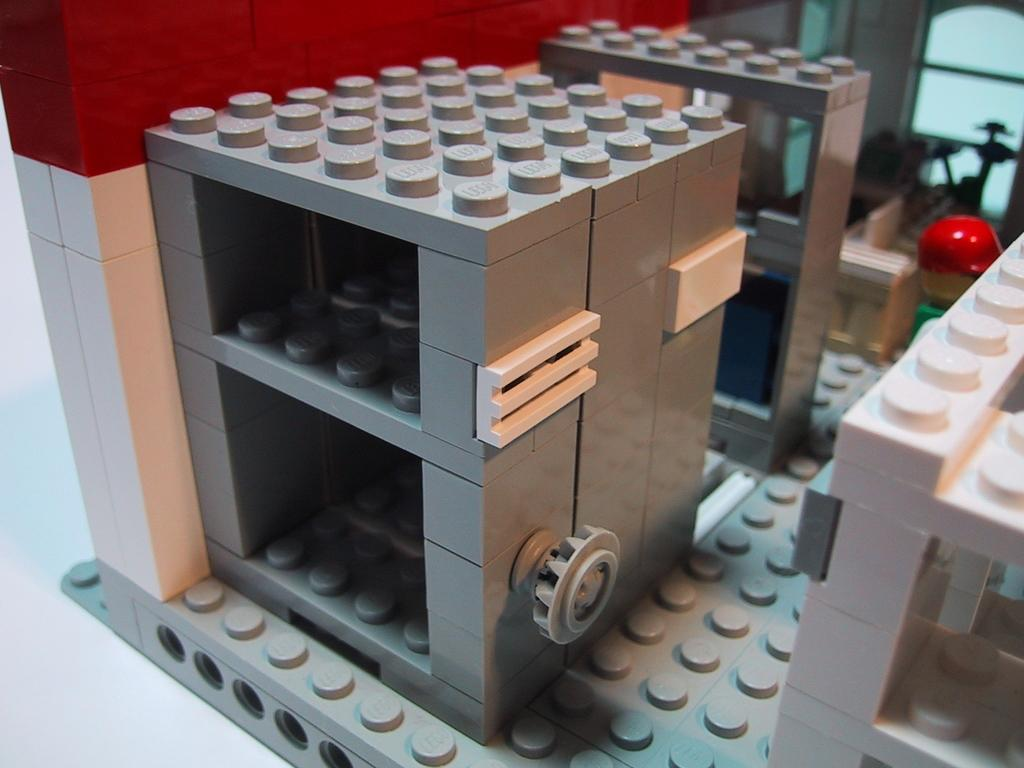What type of toy is present in the image? There are Lego bricks in the image. What other items can be seen in the image besides the Lego bricks? There are other unspecified objects in the image. What type of force can be seen acting upon the Lego bricks in the image? There is no force acting upon the Lego bricks in the image; they are stationary. Is there a hill visible in the background of the image? There is no hill present in the image. Can you see a veil covering any of the objects in the image? There is no veil present in the image. 